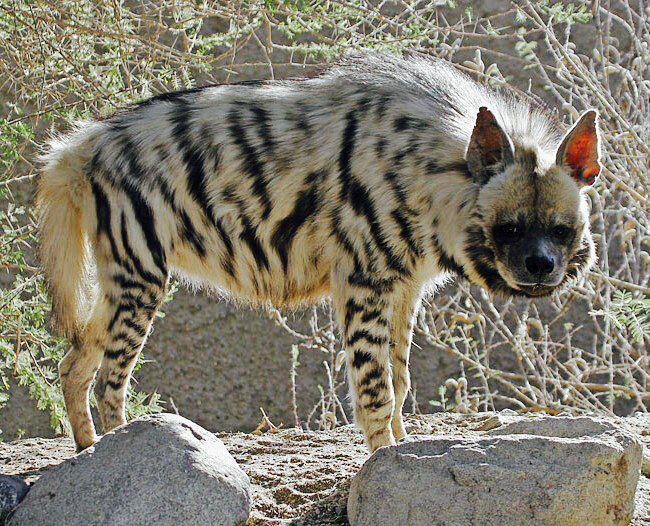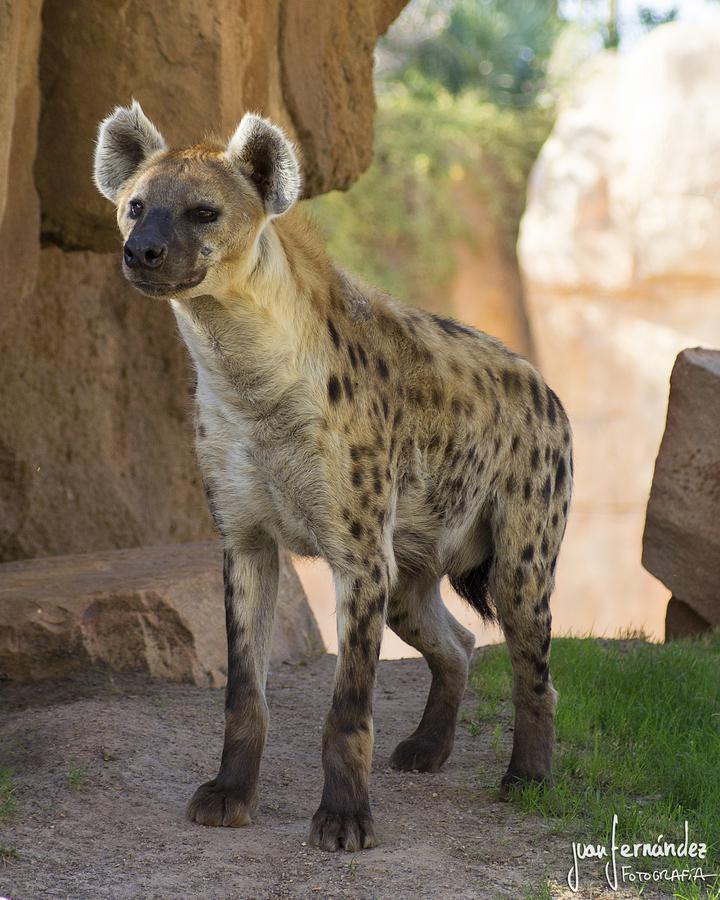The first image is the image on the left, the second image is the image on the right. Assess this claim about the two images: "Each image contains exactly one canine-type animal, and the animals on the left and right have the same kind of fur markings.". Correct or not? Answer yes or no. No. The first image is the image on the left, the second image is the image on the right. For the images displayed, is the sentence "The left and right image contains the same number of hyenas with at least one being striped." factually correct? Answer yes or no. Yes. 